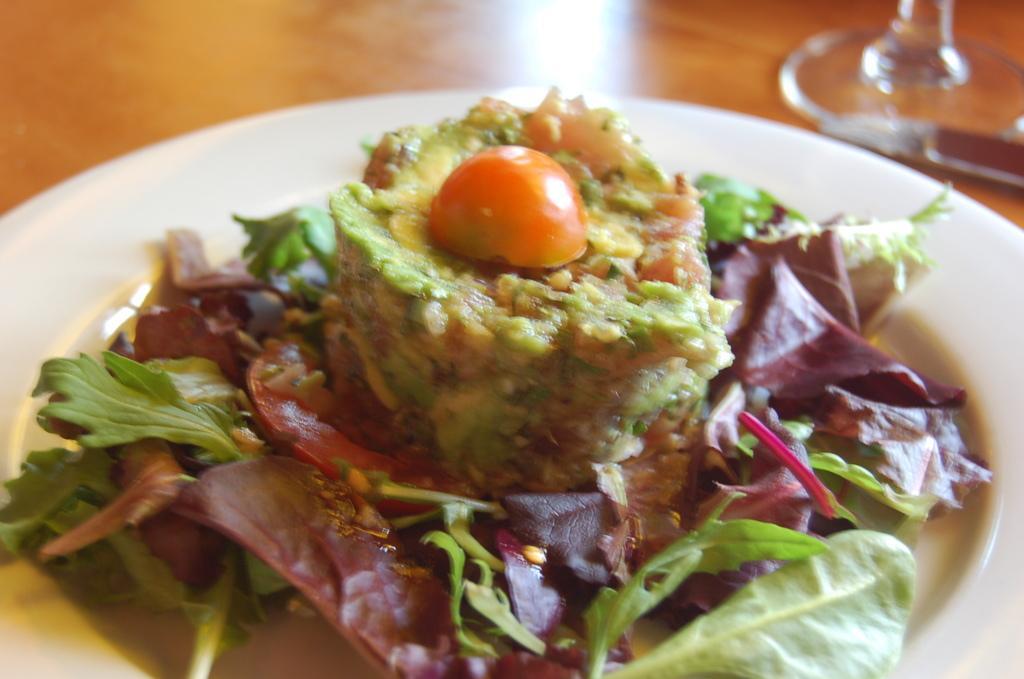How would you summarize this image in a sentence or two? In this image, we can see food on the plate and there is an object. At the bottom, there is a table. 